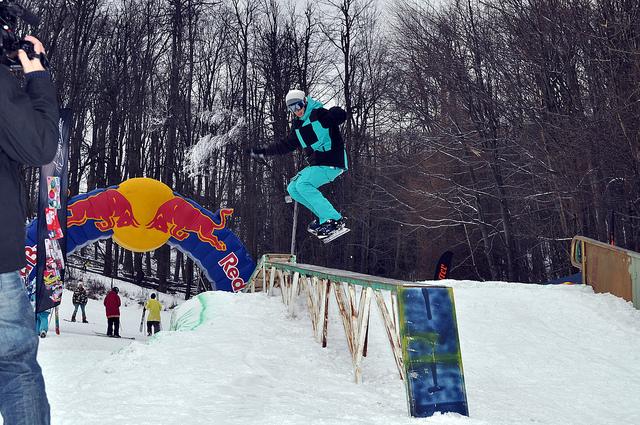Which country is it?
Concise answer only. Usa. What animal is on the sign?
Write a very short answer. Bull. Who is sponsoring this event?
Short answer required. Red bull. 